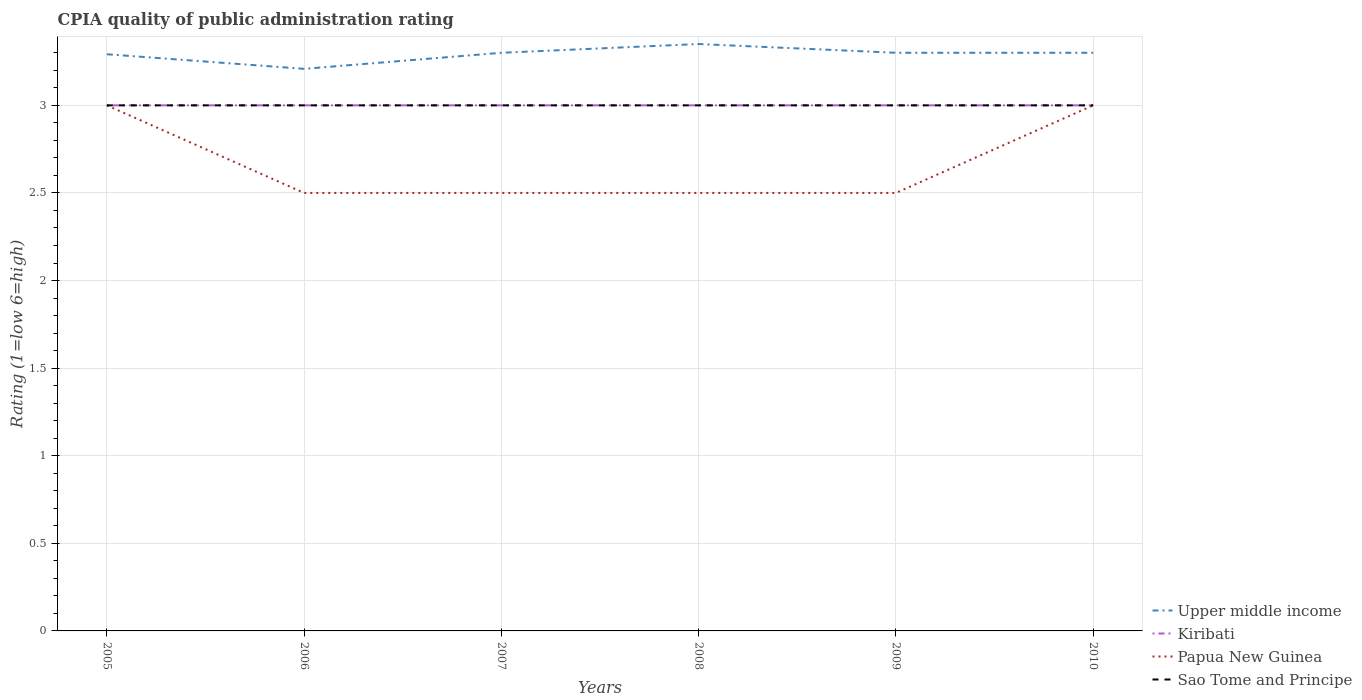Is the number of lines equal to the number of legend labels?
Your answer should be very brief. Yes. Across all years, what is the maximum CPIA rating in Kiribati?
Your response must be concise. 3. What is the total CPIA rating in Kiribati in the graph?
Provide a short and direct response. 0. How many years are there in the graph?
Keep it short and to the point. 6. What is the difference between two consecutive major ticks on the Y-axis?
Make the answer very short. 0.5. Are the values on the major ticks of Y-axis written in scientific E-notation?
Provide a short and direct response. No. Does the graph contain any zero values?
Make the answer very short. No. What is the title of the graph?
Make the answer very short. CPIA quality of public administration rating. Does "Saudi Arabia" appear as one of the legend labels in the graph?
Provide a short and direct response. No. What is the Rating (1=low 6=high) in Upper middle income in 2005?
Offer a very short reply. 3.29. What is the Rating (1=low 6=high) in Kiribati in 2005?
Your answer should be very brief. 3. What is the Rating (1=low 6=high) of Papua New Guinea in 2005?
Offer a very short reply. 3. What is the Rating (1=low 6=high) of Sao Tome and Principe in 2005?
Provide a short and direct response. 3. What is the Rating (1=low 6=high) in Upper middle income in 2006?
Provide a short and direct response. 3.21. What is the Rating (1=low 6=high) in Papua New Guinea in 2006?
Keep it short and to the point. 2.5. What is the Rating (1=low 6=high) of Sao Tome and Principe in 2006?
Offer a terse response. 3. What is the Rating (1=low 6=high) in Upper middle income in 2007?
Give a very brief answer. 3.3. What is the Rating (1=low 6=high) of Kiribati in 2007?
Give a very brief answer. 3. What is the Rating (1=low 6=high) of Papua New Guinea in 2007?
Offer a terse response. 2.5. What is the Rating (1=low 6=high) in Sao Tome and Principe in 2007?
Your answer should be very brief. 3. What is the Rating (1=low 6=high) in Upper middle income in 2008?
Make the answer very short. 3.35. What is the Rating (1=low 6=high) of Papua New Guinea in 2008?
Make the answer very short. 2.5. What is the Rating (1=low 6=high) in Upper middle income in 2009?
Make the answer very short. 3.3. What is the Rating (1=low 6=high) of Kiribati in 2009?
Make the answer very short. 3. What is the Rating (1=low 6=high) in Papua New Guinea in 2009?
Offer a very short reply. 2.5. What is the Rating (1=low 6=high) of Upper middle income in 2010?
Provide a succinct answer. 3.3. What is the Rating (1=low 6=high) in Kiribati in 2010?
Provide a short and direct response. 3. What is the Rating (1=low 6=high) of Papua New Guinea in 2010?
Give a very brief answer. 3. What is the Rating (1=low 6=high) in Sao Tome and Principe in 2010?
Your answer should be compact. 3. Across all years, what is the maximum Rating (1=low 6=high) in Upper middle income?
Your answer should be compact. 3.35. Across all years, what is the maximum Rating (1=low 6=high) of Kiribati?
Keep it short and to the point. 3. Across all years, what is the maximum Rating (1=low 6=high) of Papua New Guinea?
Ensure brevity in your answer.  3. Across all years, what is the minimum Rating (1=low 6=high) of Upper middle income?
Provide a succinct answer. 3.21. Across all years, what is the minimum Rating (1=low 6=high) in Kiribati?
Make the answer very short. 3. What is the total Rating (1=low 6=high) of Upper middle income in the graph?
Make the answer very short. 19.75. What is the total Rating (1=low 6=high) in Papua New Guinea in the graph?
Ensure brevity in your answer.  16. What is the total Rating (1=low 6=high) in Sao Tome and Principe in the graph?
Your answer should be very brief. 18. What is the difference between the Rating (1=low 6=high) of Upper middle income in 2005 and that in 2006?
Offer a very short reply. 0.08. What is the difference between the Rating (1=low 6=high) of Papua New Guinea in 2005 and that in 2006?
Your response must be concise. 0.5. What is the difference between the Rating (1=low 6=high) of Sao Tome and Principe in 2005 and that in 2006?
Offer a terse response. 0. What is the difference between the Rating (1=low 6=high) in Upper middle income in 2005 and that in 2007?
Provide a succinct answer. -0.01. What is the difference between the Rating (1=low 6=high) in Kiribati in 2005 and that in 2007?
Provide a short and direct response. 0. What is the difference between the Rating (1=low 6=high) in Papua New Guinea in 2005 and that in 2007?
Keep it short and to the point. 0.5. What is the difference between the Rating (1=low 6=high) in Upper middle income in 2005 and that in 2008?
Keep it short and to the point. -0.06. What is the difference between the Rating (1=low 6=high) of Upper middle income in 2005 and that in 2009?
Make the answer very short. -0.01. What is the difference between the Rating (1=low 6=high) of Kiribati in 2005 and that in 2009?
Offer a terse response. 0. What is the difference between the Rating (1=low 6=high) of Papua New Guinea in 2005 and that in 2009?
Offer a very short reply. 0.5. What is the difference between the Rating (1=low 6=high) of Sao Tome and Principe in 2005 and that in 2009?
Provide a short and direct response. 0. What is the difference between the Rating (1=low 6=high) in Upper middle income in 2005 and that in 2010?
Provide a short and direct response. -0.01. What is the difference between the Rating (1=low 6=high) of Kiribati in 2005 and that in 2010?
Keep it short and to the point. 0. What is the difference between the Rating (1=low 6=high) of Papua New Guinea in 2005 and that in 2010?
Give a very brief answer. 0. What is the difference between the Rating (1=low 6=high) in Upper middle income in 2006 and that in 2007?
Offer a terse response. -0.09. What is the difference between the Rating (1=low 6=high) in Papua New Guinea in 2006 and that in 2007?
Keep it short and to the point. 0. What is the difference between the Rating (1=low 6=high) in Upper middle income in 2006 and that in 2008?
Your answer should be compact. -0.14. What is the difference between the Rating (1=low 6=high) of Upper middle income in 2006 and that in 2009?
Make the answer very short. -0.09. What is the difference between the Rating (1=low 6=high) of Kiribati in 2006 and that in 2009?
Give a very brief answer. 0. What is the difference between the Rating (1=low 6=high) of Upper middle income in 2006 and that in 2010?
Offer a very short reply. -0.09. What is the difference between the Rating (1=low 6=high) in Papua New Guinea in 2006 and that in 2010?
Offer a terse response. -0.5. What is the difference between the Rating (1=low 6=high) in Sao Tome and Principe in 2006 and that in 2010?
Provide a succinct answer. 0. What is the difference between the Rating (1=low 6=high) of Upper middle income in 2007 and that in 2008?
Your answer should be very brief. -0.05. What is the difference between the Rating (1=low 6=high) in Kiribati in 2007 and that in 2008?
Your answer should be compact. 0. What is the difference between the Rating (1=low 6=high) of Papua New Guinea in 2007 and that in 2008?
Provide a short and direct response. 0. What is the difference between the Rating (1=low 6=high) of Sao Tome and Principe in 2007 and that in 2008?
Ensure brevity in your answer.  0. What is the difference between the Rating (1=low 6=high) of Kiribati in 2007 and that in 2009?
Provide a short and direct response. 0. What is the difference between the Rating (1=low 6=high) of Papua New Guinea in 2007 and that in 2009?
Keep it short and to the point. 0. What is the difference between the Rating (1=low 6=high) of Sao Tome and Principe in 2007 and that in 2009?
Make the answer very short. 0. What is the difference between the Rating (1=low 6=high) of Kiribati in 2007 and that in 2010?
Ensure brevity in your answer.  0. What is the difference between the Rating (1=low 6=high) in Sao Tome and Principe in 2007 and that in 2010?
Offer a terse response. 0. What is the difference between the Rating (1=low 6=high) of Papua New Guinea in 2008 and that in 2009?
Your answer should be compact. 0. What is the difference between the Rating (1=low 6=high) of Sao Tome and Principe in 2008 and that in 2009?
Give a very brief answer. 0. What is the difference between the Rating (1=low 6=high) in Papua New Guinea in 2008 and that in 2010?
Provide a succinct answer. -0.5. What is the difference between the Rating (1=low 6=high) of Sao Tome and Principe in 2008 and that in 2010?
Offer a very short reply. 0. What is the difference between the Rating (1=low 6=high) of Papua New Guinea in 2009 and that in 2010?
Your answer should be compact. -0.5. What is the difference between the Rating (1=low 6=high) in Sao Tome and Principe in 2009 and that in 2010?
Provide a short and direct response. 0. What is the difference between the Rating (1=low 6=high) of Upper middle income in 2005 and the Rating (1=low 6=high) of Kiribati in 2006?
Give a very brief answer. 0.29. What is the difference between the Rating (1=low 6=high) in Upper middle income in 2005 and the Rating (1=low 6=high) in Papua New Guinea in 2006?
Provide a short and direct response. 0.79. What is the difference between the Rating (1=low 6=high) in Upper middle income in 2005 and the Rating (1=low 6=high) in Sao Tome and Principe in 2006?
Your answer should be compact. 0.29. What is the difference between the Rating (1=low 6=high) in Kiribati in 2005 and the Rating (1=low 6=high) in Papua New Guinea in 2006?
Offer a very short reply. 0.5. What is the difference between the Rating (1=low 6=high) of Upper middle income in 2005 and the Rating (1=low 6=high) of Kiribati in 2007?
Make the answer very short. 0.29. What is the difference between the Rating (1=low 6=high) of Upper middle income in 2005 and the Rating (1=low 6=high) of Papua New Guinea in 2007?
Provide a short and direct response. 0.79. What is the difference between the Rating (1=low 6=high) in Upper middle income in 2005 and the Rating (1=low 6=high) in Sao Tome and Principe in 2007?
Provide a short and direct response. 0.29. What is the difference between the Rating (1=low 6=high) in Kiribati in 2005 and the Rating (1=low 6=high) in Sao Tome and Principe in 2007?
Your answer should be compact. 0. What is the difference between the Rating (1=low 6=high) in Papua New Guinea in 2005 and the Rating (1=low 6=high) in Sao Tome and Principe in 2007?
Your response must be concise. 0. What is the difference between the Rating (1=low 6=high) of Upper middle income in 2005 and the Rating (1=low 6=high) of Kiribati in 2008?
Make the answer very short. 0.29. What is the difference between the Rating (1=low 6=high) of Upper middle income in 2005 and the Rating (1=low 6=high) of Papua New Guinea in 2008?
Your answer should be very brief. 0.79. What is the difference between the Rating (1=low 6=high) of Upper middle income in 2005 and the Rating (1=low 6=high) of Sao Tome and Principe in 2008?
Ensure brevity in your answer.  0.29. What is the difference between the Rating (1=low 6=high) in Kiribati in 2005 and the Rating (1=low 6=high) in Papua New Guinea in 2008?
Your response must be concise. 0.5. What is the difference between the Rating (1=low 6=high) of Upper middle income in 2005 and the Rating (1=low 6=high) of Kiribati in 2009?
Your answer should be compact. 0.29. What is the difference between the Rating (1=low 6=high) in Upper middle income in 2005 and the Rating (1=low 6=high) in Papua New Guinea in 2009?
Your answer should be very brief. 0.79. What is the difference between the Rating (1=low 6=high) of Upper middle income in 2005 and the Rating (1=low 6=high) of Sao Tome and Principe in 2009?
Provide a short and direct response. 0.29. What is the difference between the Rating (1=low 6=high) in Kiribati in 2005 and the Rating (1=low 6=high) in Sao Tome and Principe in 2009?
Your answer should be compact. 0. What is the difference between the Rating (1=low 6=high) in Upper middle income in 2005 and the Rating (1=low 6=high) in Kiribati in 2010?
Make the answer very short. 0.29. What is the difference between the Rating (1=low 6=high) in Upper middle income in 2005 and the Rating (1=low 6=high) in Papua New Guinea in 2010?
Make the answer very short. 0.29. What is the difference between the Rating (1=low 6=high) of Upper middle income in 2005 and the Rating (1=low 6=high) of Sao Tome and Principe in 2010?
Your response must be concise. 0.29. What is the difference between the Rating (1=low 6=high) in Papua New Guinea in 2005 and the Rating (1=low 6=high) in Sao Tome and Principe in 2010?
Keep it short and to the point. 0. What is the difference between the Rating (1=low 6=high) of Upper middle income in 2006 and the Rating (1=low 6=high) of Kiribati in 2007?
Keep it short and to the point. 0.21. What is the difference between the Rating (1=low 6=high) in Upper middle income in 2006 and the Rating (1=low 6=high) in Papua New Guinea in 2007?
Make the answer very short. 0.71. What is the difference between the Rating (1=low 6=high) of Upper middle income in 2006 and the Rating (1=low 6=high) of Sao Tome and Principe in 2007?
Offer a terse response. 0.21. What is the difference between the Rating (1=low 6=high) of Kiribati in 2006 and the Rating (1=low 6=high) of Papua New Guinea in 2007?
Offer a very short reply. 0.5. What is the difference between the Rating (1=low 6=high) of Papua New Guinea in 2006 and the Rating (1=low 6=high) of Sao Tome and Principe in 2007?
Give a very brief answer. -0.5. What is the difference between the Rating (1=low 6=high) of Upper middle income in 2006 and the Rating (1=low 6=high) of Kiribati in 2008?
Give a very brief answer. 0.21. What is the difference between the Rating (1=low 6=high) of Upper middle income in 2006 and the Rating (1=low 6=high) of Papua New Guinea in 2008?
Keep it short and to the point. 0.71. What is the difference between the Rating (1=low 6=high) in Upper middle income in 2006 and the Rating (1=low 6=high) in Sao Tome and Principe in 2008?
Give a very brief answer. 0.21. What is the difference between the Rating (1=low 6=high) in Kiribati in 2006 and the Rating (1=low 6=high) in Papua New Guinea in 2008?
Your response must be concise. 0.5. What is the difference between the Rating (1=low 6=high) in Kiribati in 2006 and the Rating (1=low 6=high) in Sao Tome and Principe in 2008?
Offer a terse response. 0. What is the difference between the Rating (1=low 6=high) of Upper middle income in 2006 and the Rating (1=low 6=high) of Kiribati in 2009?
Give a very brief answer. 0.21. What is the difference between the Rating (1=low 6=high) in Upper middle income in 2006 and the Rating (1=low 6=high) in Papua New Guinea in 2009?
Ensure brevity in your answer.  0.71. What is the difference between the Rating (1=low 6=high) of Upper middle income in 2006 and the Rating (1=low 6=high) of Sao Tome and Principe in 2009?
Provide a short and direct response. 0.21. What is the difference between the Rating (1=low 6=high) of Kiribati in 2006 and the Rating (1=low 6=high) of Sao Tome and Principe in 2009?
Make the answer very short. 0. What is the difference between the Rating (1=low 6=high) in Papua New Guinea in 2006 and the Rating (1=low 6=high) in Sao Tome and Principe in 2009?
Your answer should be very brief. -0.5. What is the difference between the Rating (1=low 6=high) of Upper middle income in 2006 and the Rating (1=low 6=high) of Kiribati in 2010?
Provide a succinct answer. 0.21. What is the difference between the Rating (1=low 6=high) of Upper middle income in 2006 and the Rating (1=low 6=high) of Papua New Guinea in 2010?
Keep it short and to the point. 0.21. What is the difference between the Rating (1=low 6=high) of Upper middle income in 2006 and the Rating (1=low 6=high) of Sao Tome and Principe in 2010?
Ensure brevity in your answer.  0.21. What is the difference between the Rating (1=low 6=high) in Kiribati in 2006 and the Rating (1=low 6=high) in Papua New Guinea in 2010?
Make the answer very short. 0. What is the difference between the Rating (1=low 6=high) of Upper middle income in 2007 and the Rating (1=low 6=high) of Kiribati in 2008?
Make the answer very short. 0.3. What is the difference between the Rating (1=low 6=high) in Upper middle income in 2007 and the Rating (1=low 6=high) in Papua New Guinea in 2008?
Provide a succinct answer. 0.8. What is the difference between the Rating (1=low 6=high) of Kiribati in 2007 and the Rating (1=low 6=high) of Sao Tome and Principe in 2008?
Your answer should be very brief. 0. What is the difference between the Rating (1=low 6=high) in Papua New Guinea in 2007 and the Rating (1=low 6=high) in Sao Tome and Principe in 2008?
Provide a short and direct response. -0.5. What is the difference between the Rating (1=low 6=high) of Kiribati in 2007 and the Rating (1=low 6=high) of Papua New Guinea in 2009?
Provide a short and direct response. 0.5. What is the difference between the Rating (1=low 6=high) of Kiribati in 2007 and the Rating (1=low 6=high) of Sao Tome and Principe in 2009?
Your response must be concise. 0. What is the difference between the Rating (1=low 6=high) in Upper middle income in 2007 and the Rating (1=low 6=high) in Kiribati in 2010?
Offer a very short reply. 0.3. What is the difference between the Rating (1=low 6=high) in Upper middle income in 2007 and the Rating (1=low 6=high) in Papua New Guinea in 2010?
Give a very brief answer. 0.3. What is the difference between the Rating (1=low 6=high) in Upper middle income in 2007 and the Rating (1=low 6=high) in Sao Tome and Principe in 2010?
Make the answer very short. 0.3. What is the difference between the Rating (1=low 6=high) in Kiribati in 2007 and the Rating (1=low 6=high) in Papua New Guinea in 2010?
Ensure brevity in your answer.  0. What is the difference between the Rating (1=low 6=high) of Papua New Guinea in 2007 and the Rating (1=low 6=high) of Sao Tome and Principe in 2010?
Offer a very short reply. -0.5. What is the difference between the Rating (1=low 6=high) of Upper middle income in 2008 and the Rating (1=low 6=high) of Sao Tome and Principe in 2009?
Provide a succinct answer. 0.35. What is the difference between the Rating (1=low 6=high) of Kiribati in 2008 and the Rating (1=low 6=high) of Papua New Guinea in 2009?
Give a very brief answer. 0.5. What is the difference between the Rating (1=low 6=high) of Kiribati in 2008 and the Rating (1=low 6=high) of Sao Tome and Principe in 2009?
Your answer should be compact. 0. What is the difference between the Rating (1=low 6=high) of Upper middle income in 2008 and the Rating (1=low 6=high) of Sao Tome and Principe in 2010?
Provide a succinct answer. 0.35. What is the difference between the Rating (1=low 6=high) in Kiribati in 2008 and the Rating (1=low 6=high) in Papua New Guinea in 2010?
Give a very brief answer. 0. What is the difference between the Rating (1=low 6=high) of Kiribati in 2008 and the Rating (1=low 6=high) of Sao Tome and Principe in 2010?
Your response must be concise. 0. What is the difference between the Rating (1=low 6=high) of Upper middle income in 2009 and the Rating (1=low 6=high) of Papua New Guinea in 2010?
Your answer should be very brief. 0.3. What is the difference between the Rating (1=low 6=high) in Upper middle income in 2009 and the Rating (1=low 6=high) in Sao Tome and Principe in 2010?
Your response must be concise. 0.3. What is the difference between the Rating (1=low 6=high) in Kiribati in 2009 and the Rating (1=low 6=high) in Sao Tome and Principe in 2010?
Give a very brief answer. 0. What is the difference between the Rating (1=low 6=high) in Papua New Guinea in 2009 and the Rating (1=low 6=high) in Sao Tome and Principe in 2010?
Offer a very short reply. -0.5. What is the average Rating (1=low 6=high) of Upper middle income per year?
Provide a succinct answer. 3.29. What is the average Rating (1=low 6=high) in Papua New Guinea per year?
Your response must be concise. 2.67. In the year 2005, what is the difference between the Rating (1=low 6=high) in Upper middle income and Rating (1=low 6=high) in Kiribati?
Keep it short and to the point. 0.29. In the year 2005, what is the difference between the Rating (1=low 6=high) of Upper middle income and Rating (1=low 6=high) of Papua New Guinea?
Your response must be concise. 0.29. In the year 2005, what is the difference between the Rating (1=low 6=high) in Upper middle income and Rating (1=low 6=high) in Sao Tome and Principe?
Keep it short and to the point. 0.29. In the year 2006, what is the difference between the Rating (1=low 6=high) of Upper middle income and Rating (1=low 6=high) of Kiribati?
Your response must be concise. 0.21. In the year 2006, what is the difference between the Rating (1=low 6=high) of Upper middle income and Rating (1=low 6=high) of Papua New Guinea?
Offer a very short reply. 0.71. In the year 2006, what is the difference between the Rating (1=low 6=high) in Upper middle income and Rating (1=low 6=high) in Sao Tome and Principe?
Keep it short and to the point. 0.21. In the year 2006, what is the difference between the Rating (1=low 6=high) of Kiribati and Rating (1=low 6=high) of Papua New Guinea?
Your response must be concise. 0.5. In the year 2007, what is the difference between the Rating (1=low 6=high) in Upper middle income and Rating (1=low 6=high) in Kiribati?
Make the answer very short. 0.3. In the year 2007, what is the difference between the Rating (1=low 6=high) in Upper middle income and Rating (1=low 6=high) in Papua New Guinea?
Your answer should be compact. 0.8. In the year 2007, what is the difference between the Rating (1=low 6=high) in Upper middle income and Rating (1=low 6=high) in Sao Tome and Principe?
Offer a very short reply. 0.3. In the year 2007, what is the difference between the Rating (1=low 6=high) in Kiribati and Rating (1=low 6=high) in Sao Tome and Principe?
Provide a succinct answer. 0. In the year 2008, what is the difference between the Rating (1=low 6=high) in Upper middle income and Rating (1=low 6=high) in Papua New Guinea?
Make the answer very short. 0.85. In the year 2008, what is the difference between the Rating (1=low 6=high) of Upper middle income and Rating (1=low 6=high) of Sao Tome and Principe?
Offer a very short reply. 0.35. In the year 2008, what is the difference between the Rating (1=low 6=high) in Kiribati and Rating (1=low 6=high) in Papua New Guinea?
Offer a very short reply. 0.5. In the year 2008, what is the difference between the Rating (1=low 6=high) in Papua New Guinea and Rating (1=low 6=high) in Sao Tome and Principe?
Offer a very short reply. -0.5. In the year 2009, what is the difference between the Rating (1=low 6=high) in Upper middle income and Rating (1=low 6=high) in Sao Tome and Principe?
Your answer should be compact. 0.3. In the year 2009, what is the difference between the Rating (1=low 6=high) of Kiribati and Rating (1=low 6=high) of Papua New Guinea?
Offer a terse response. 0.5. In the year 2010, what is the difference between the Rating (1=low 6=high) in Upper middle income and Rating (1=low 6=high) in Papua New Guinea?
Provide a short and direct response. 0.3. What is the ratio of the Rating (1=low 6=high) in Upper middle income in 2005 to that in 2006?
Make the answer very short. 1.03. What is the ratio of the Rating (1=low 6=high) in Kiribati in 2005 to that in 2007?
Your response must be concise. 1. What is the ratio of the Rating (1=low 6=high) of Sao Tome and Principe in 2005 to that in 2007?
Give a very brief answer. 1. What is the ratio of the Rating (1=low 6=high) of Upper middle income in 2005 to that in 2008?
Offer a terse response. 0.98. What is the ratio of the Rating (1=low 6=high) of Kiribati in 2005 to that in 2008?
Give a very brief answer. 1. What is the ratio of the Rating (1=low 6=high) in Papua New Guinea in 2005 to that in 2008?
Offer a very short reply. 1.2. What is the ratio of the Rating (1=low 6=high) in Sao Tome and Principe in 2005 to that in 2008?
Your answer should be very brief. 1. What is the ratio of the Rating (1=low 6=high) in Kiribati in 2005 to that in 2009?
Ensure brevity in your answer.  1. What is the ratio of the Rating (1=low 6=high) in Papua New Guinea in 2005 to that in 2009?
Provide a short and direct response. 1.2. What is the ratio of the Rating (1=low 6=high) in Sao Tome and Principe in 2005 to that in 2009?
Your answer should be very brief. 1. What is the ratio of the Rating (1=low 6=high) of Upper middle income in 2005 to that in 2010?
Make the answer very short. 1. What is the ratio of the Rating (1=low 6=high) of Upper middle income in 2006 to that in 2007?
Offer a very short reply. 0.97. What is the ratio of the Rating (1=low 6=high) in Sao Tome and Principe in 2006 to that in 2007?
Keep it short and to the point. 1. What is the ratio of the Rating (1=low 6=high) in Upper middle income in 2006 to that in 2008?
Make the answer very short. 0.96. What is the ratio of the Rating (1=low 6=high) in Kiribati in 2006 to that in 2008?
Provide a succinct answer. 1. What is the ratio of the Rating (1=low 6=high) of Papua New Guinea in 2006 to that in 2008?
Your answer should be compact. 1. What is the ratio of the Rating (1=low 6=high) of Sao Tome and Principe in 2006 to that in 2008?
Your response must be concise. 1. What is the ratio of the Rating (1=low 6=high) in Upper middle income in 2006 to that in 2009?
Offer a very short reply. 0.97. What is the ratio of the Rating (1=low 6=high) in Kiribati in 2006 to that in 2009?
Keep it short and to the point. 1. What is the ratio of the Rating (1=low 6=high) in Upper middle income in 2006 to that in 2010?
Your answer should be compact. 0.97. What is the ratio of the Rating (1=low 6=high) in Kiribati in 2006 to that in 2010?
Keep it short and to the point. 1. What is the ratio of the Rating (1=low 6=high) in Upper middle income in 2007 to that in 2008?
Provide a short and direct response. 0.99. What is the ratio of the Rating (1=low 6=high) in Kiribati in 2007 to that in 2008?
Your answer should be compact. 1. What is the ratio of the Rating (1=low 6=high) of Upper middle income in 2007 to that in 2009?
Ensure brevity in your answer.  1. What is the ratio of the Rating (1=low 6=high) in Papua New Guinea in 2007 to that in 2009?
Provide a succinct answer. 1. What is the ratio of the Rating (1=low 6=high) of Sao Tome and Principe in 2007 to that in 2009?
Offer a very short reply. 1. What is the ratio of the Rating (1=low 6=high) of Kiribati in 2007 to that in 2010?
Provide a short and direct response. 1. What is the ratio of the Rating (1=low 6=high) in Upper middle income in 2008 to that in 2009?
Offer a very short reply. 1.02. What is the ratio of the Rating (1=low 6=high) in Sao Tome and Principe in 2008 to that in 2009?
Your response must be concise. 1. What is the ratio of the Rating (1=low 6=high) of Upper middle income in 2008 to that in 2010?
Keep it short and to the point. 1.02. What is the ratio of the Rating (1=low 6=high) of Kiribati in 2008 to that in 2010?
Offer a very short reply. 1. What is the ratio of the Rating (1=low 6=high) in Papua New Guinea in 2008 to that in 2010?
Offer a terse response. 0.83. What is the ratio of the Rating (1=low 6=high) in Kiribati in 2009 to that in 2010?
Offer a very short reply. 1. What is the difference between the highest and the second highest Rating (1=low 6=high) of Upper middle income?
Offer a very short reply. 0.05. What is the difference between the highest and the second highest Rating (1=low 6=high) in Kiribati?
Your answer should be compact. 0. What is the difference between the highest and the lowest Rating (1=low 6=high) in Upper middle income?
Give a very brief answer. 0.14. What is the difference between the highest and the lowest Rating (1=low 6=high) in Kiribati?
Give a very brief answer. 0. What is the difference between the highest and the lowest Rating (1=low 6=high) of Papua New Guinea?
Ensure brevity in your answer.  0.5. What is the difference between the highest and the lowest Rating (1=low 6=high) of Sao Tome and Principe?
Give a very brief answer. 0. 